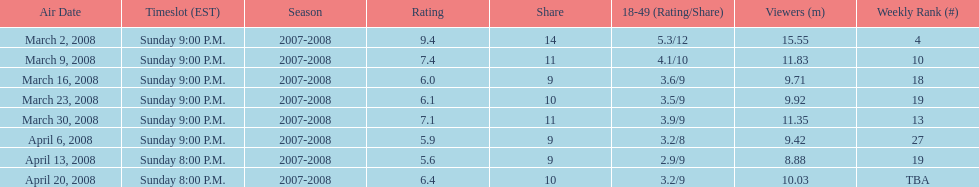Which show had the highest rating? 1. 